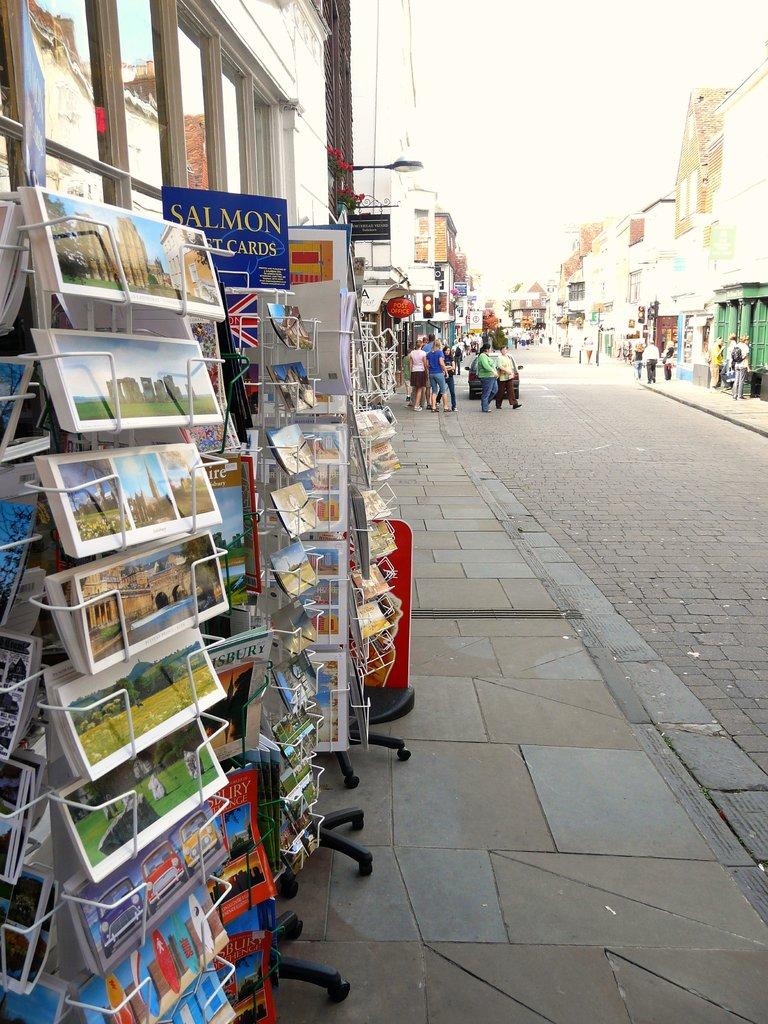What are they selling?
Provide a short and direct response. Post cards. What fish is on the blue sign?
Provide a succinct answer. Salmon. 